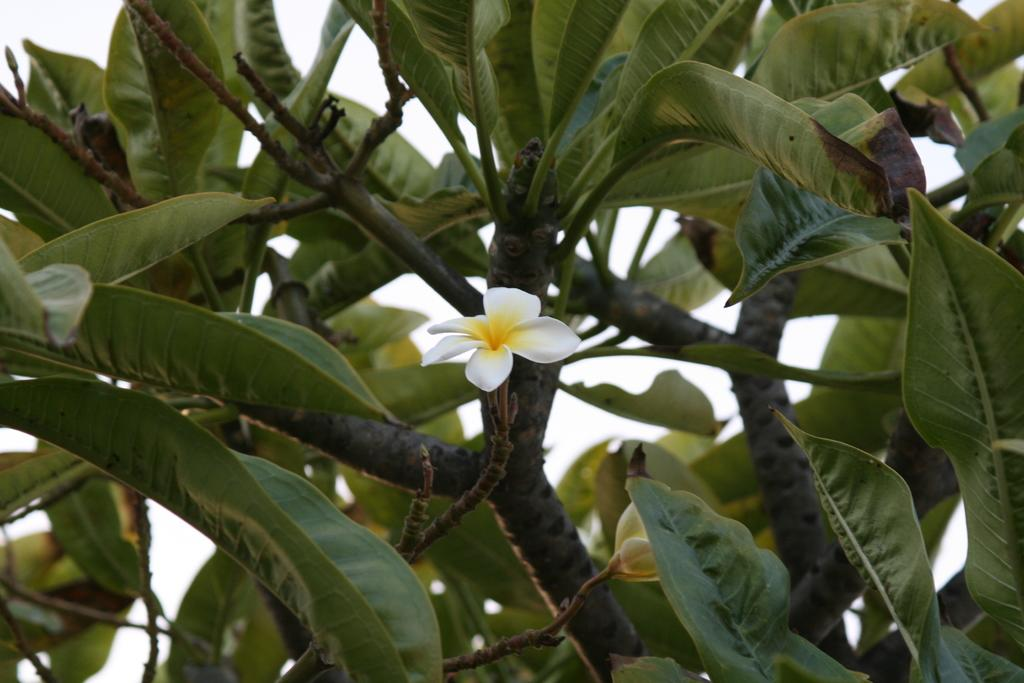What is the main subject of the image? The main subject of the image is a tree. What can be observed on the tree? There are white-colored flowers on the tree. What is visible in the background of the image? The sky is visible at the top of the image. How many hands are visible holding the suit in the bedroom in the image? There is no suit or bedroom present in the image; it features a tree with white-colored flowers and a visible sky. 